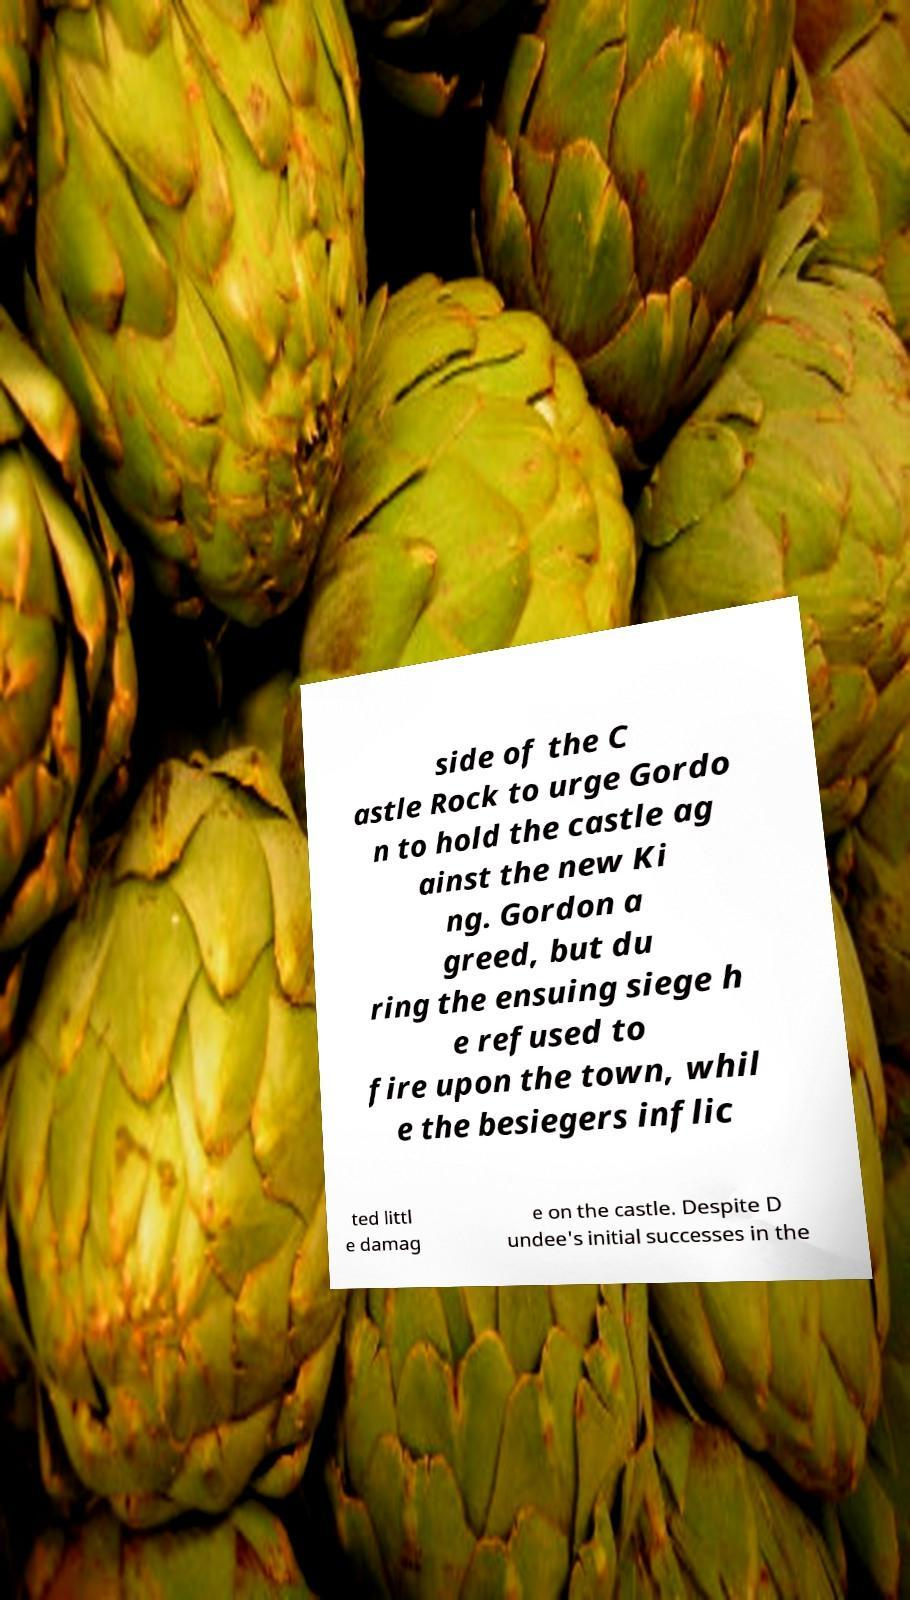Could you assist in decoding the text presented in this image and type it out clearly? side of the C astle Rock to urge Gordo n to hold the castle ag ainst the new Ki ng. Gordon a greed, but du ring the ensuing siege h e refused to fire upon the town, whil e the besiegers inflic ted littl e damag e on the castle. Despite D undee's initial successes in the 